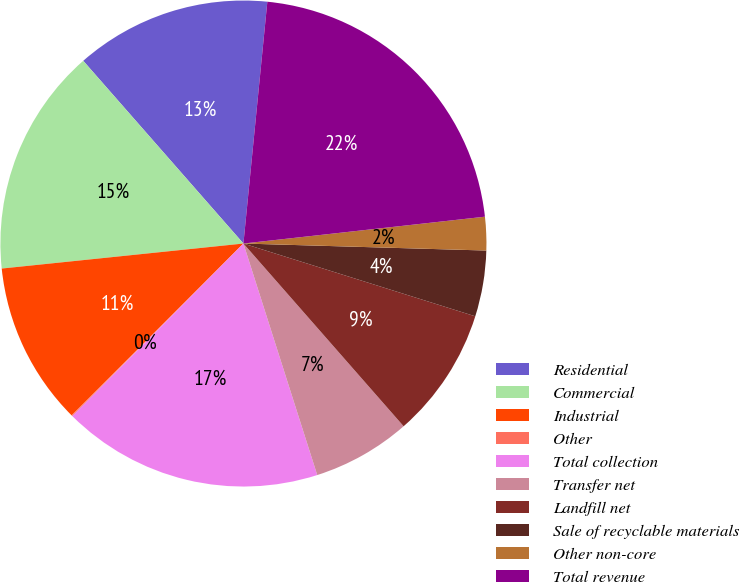Convert chart to OTSL. <chart><loc_0><loc_0><loc_500><loc_500><pie_chart><fcel>Residential<fcel>Commercial<fcel>Industrial<fcel>Other<fcel>Total collection<fcel>Transfer net<fcel>Landfill net<fcel>Sale of recyclable materials<fcel>Other non-core<fcel>Total revenue<nl><fcel>13.02%<fcel>15.18%<fcel>10.86%<fcel>0.06%<fcel>17.34%<fcel>6.54%<fcel>8.7%<fcel>4.38%<fcel>2.22%<fcel>21.66%<nl></chart> 